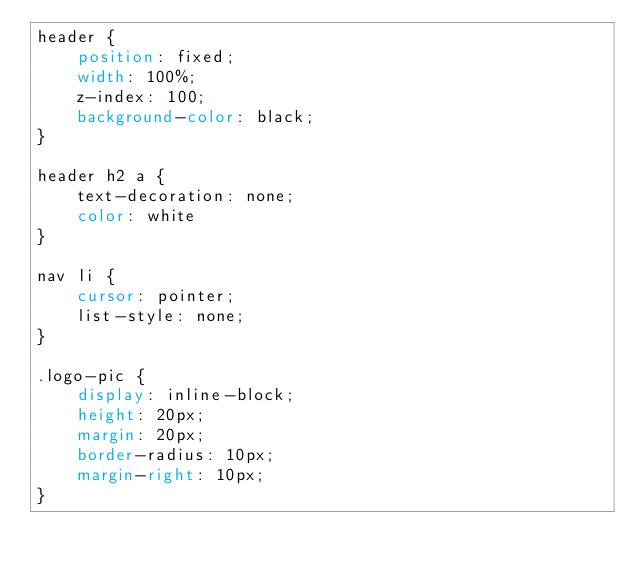<code> <loc_0><loc_0><loc_500><loc_500><_CSS_>header {
    position: fixed;
    width: 100%;
    z-index: 100;
    background-color: black;
}

header h2 a {
    text-decoration: none;
    color: white
}

nav li {
    cursor: pointer;
    list-style: none;
}

.logo-pic {
    display: inline-block;
    height: 20px;
    margin: 20px;
    border-radius: 10px;
    margin-right: 10px;
}</code> 